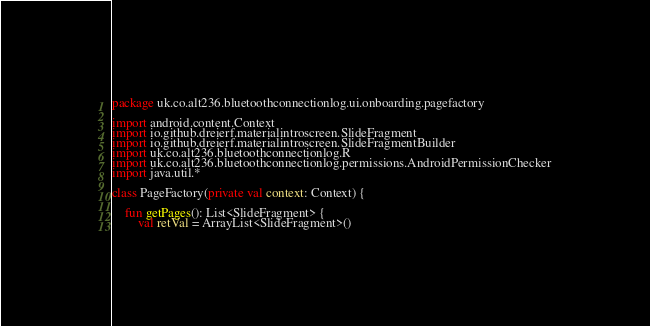<code> <loc_0><loc_0><loc_500><loc_500><_Kotlin_>package uk.co.alt236.bluetoothconnectionlog.ui.onboarding.pagefactory

import android.content.Context
import io.github.dreierf.materialintroscreen.SlideFragment
import io.github.dreierf.materialintroscreen.SlideFragmentBuilder
import uk.co.alt236.bluetoothconnectionlog.R
import uk.co.alt236.bluetoothconnectionlog.permissions.AndroidPermissionChecker
import java.util.*

class PageFactory(private val context: Context) {

    fun getPages(): List<SlideFragment> {
        val retVal = ArrayList<SlideFragment>()
</code> 